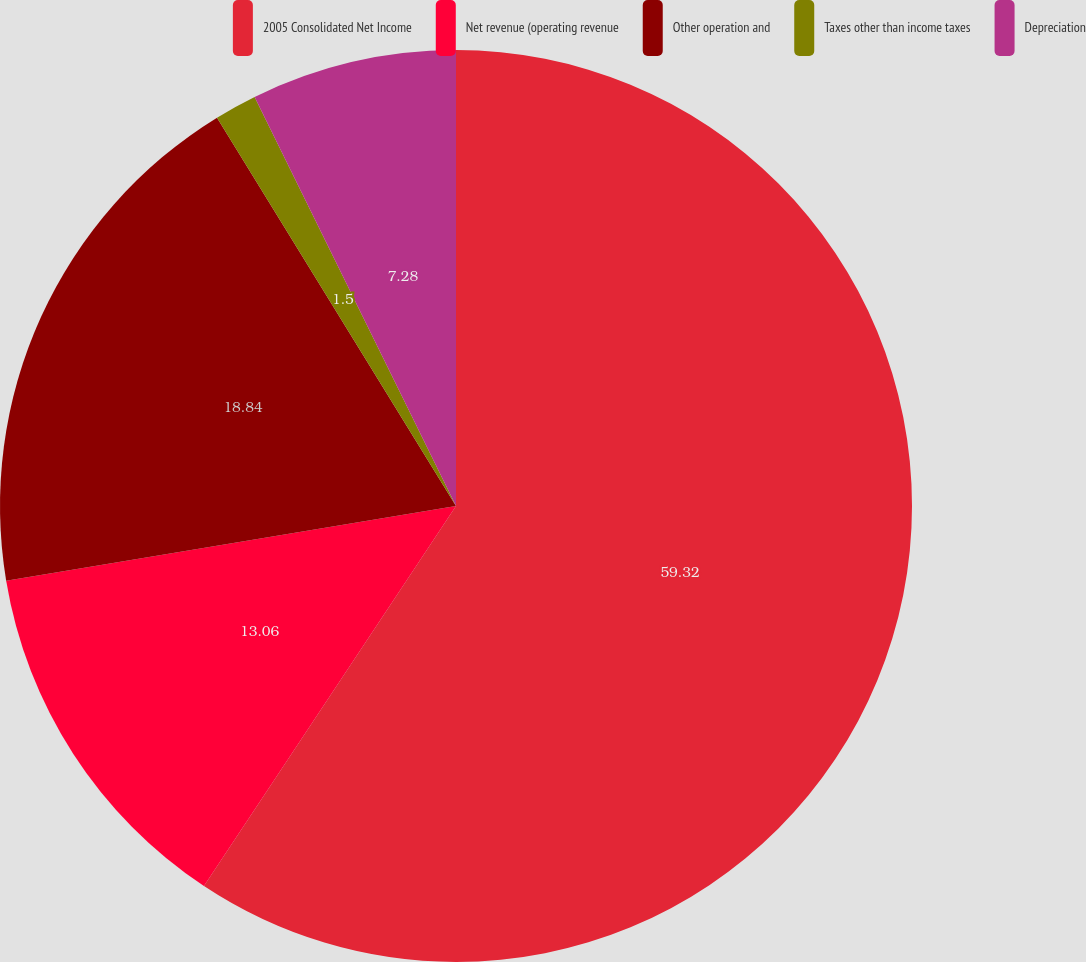Convert chart. <chart><loc_0><loc_0><loc_500><loc_500><pie_chart><fcel>2005 Consolidated Net Income<fcel>Net revenue (operating revenue<fcel>Other operation and<fcel>Taxes other than income taxes<fcel>Depreciation<nl><fcel>59.32%<fcel>13.06%<fcel>18.84%<fcel>1.5%<fcel>7.28%<nl></chart> 